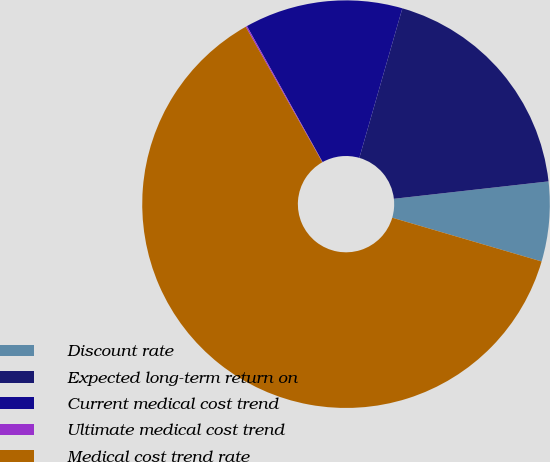Convert chart. <chart><loc_0><loc_0><loc_500><loc_500><pie_chart><fcel>Discount rate<fcel>Expected long-term return on<fcel>Current medical cost trend<fcel>Ultimate medical cost trend<fcel>Medical cost trend rate<nl><fcel>6.32%<fcel>18.76%<fcel>12.54%<fcel>0.11%<fcel>62.27%<nl></chart> 